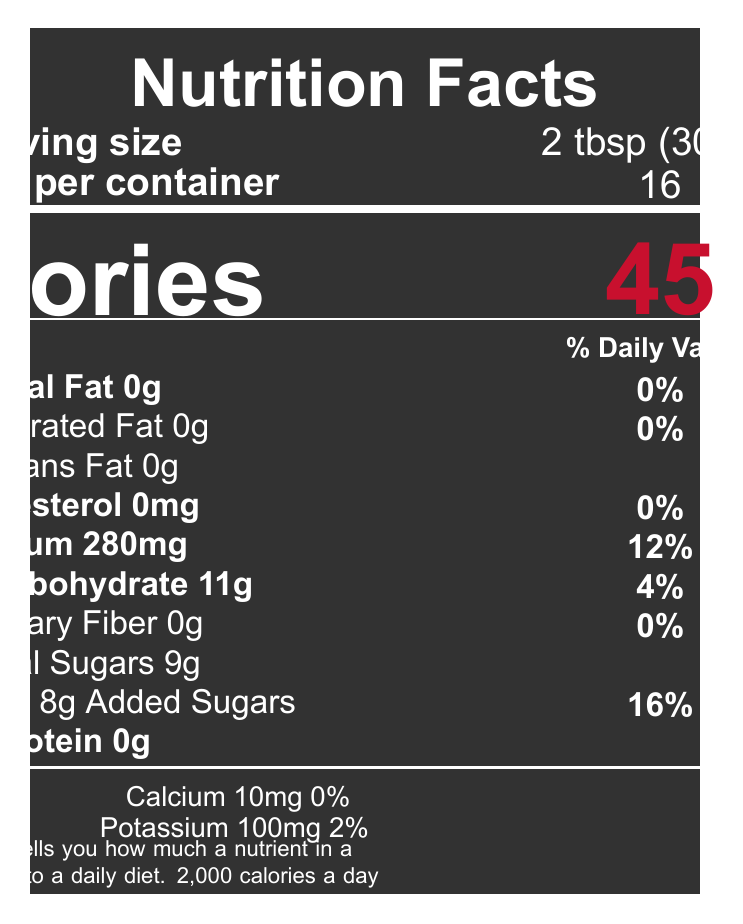What is the serving size for Pit Stop BBQ Sauce? The serving size is mentioned next to the text "Serving size" in the document.
Answer: 2 tbsp (30 ml) How many calories are in one serving of the barbecue sauce? The number of calories is specified in large, bold font in the document.
Answer: 45 What percentage of the daily value of sodium is in one serving? The document lists the sodium content as 280mg with a daily value of 12%.
Answer: 12% What ingredient listed can be a potential allergen? The allergen information specifies that soy, found in Worcestershire sauce, is a potential allergen.
Answer: Soy (in Worcestershire sauce) What is the total carbohydrate content in a serving of this sauce? The total carbohydrate content is listed as 11g with a daily value of 4%.
Answer: 11g What is the manufacturer of the Pit Stop BBQ Sauce? The manufacturer information is located at the bottom of the provided data.
Answer: Richmond Raceway Foods, Richmond, VA How should the barbecue sauce be stored after opening? The storage instructions clearly state to refrigerate after opening.
Answer: Refrigerate after opening Which vitamin is entirely absent in this barbecue sauce? A. Vitamin D B. Vitamin C C. Vitamin B12 D. Iron The document lists Vitamin D as 0mcg with a daily value of 0%.
Answer: A. Vitamin D How much dietary fiber does a serving of the barbecue sauce contain? The dietary fiber content is listed as 0g with a daily value of 0%.
Answer: 0g Is there any protein in a serving of the barbecue sauce? The protein content is listed as 0g in the document.
Answer: No Which of the following components has a daily value of 16%? 1. Total Sugars 2. Added Sugars 3. Saturated Fat 4. Potassium The added sugars are listed as 8g with a daily value of 16%.
Answer: 2. Added Sugars Is this sauce connected to any racing events? The sauce is marked as the "Official sauce of the Virginia International Raceway."
Answer: Yes What are the main flavors and ingredients in this barbecue sauce based on the ingredient list? The document lists all these items as ingredients.
Answer: Tomato paste, Apple cider vinegar, Molasses, Brown sugar, Water, Worcestershire sauce, Salt, Onion powder, Garlic powder, Black pepper, Red pepper flakes, Liquid smoke Summarize the detailed nutritional information and additional data provided about Pit Stop BBQ Sauce. This summary encapsulates the primary nutritional facts, allergen info, manufacturer, racing connection, and storage instruction provided in the document.
Answer: The Pit Stop BBQ Sauce comes in a serving size of 2 tbsp (30 ml) with 16 servings per container. Each serving has 45 calories and contains 0g of total fat, saturated fat, and trans fat, 0mg of cholesterol, 280mg of sodium (12% daily value), 11g of total carbohydrate (4% daily value), 0g of dietary fiber, 9g of total sugars which includes 8g of added sugars (16% daily value), and 0g of protein. The sauce contains traces of Vitamin D, Calcium, Iron, and Potassium. It has notable allergens due to soy in the Worcestershire sauce. The manufacturer is Richmond Raceway Foods in Richmond, VA, and it's the official sauce of the Virginia International Raceway. The storage instruction advises refrigerating after opening. What is the daily value percentage for iron in one serving of the sauce? Iron content is listed as 0.2mg with a daily value of 2%.
Answer: 2% Is the total fat content in the barbecue sauce higher than 1g? The total fat content is 0g as stated in the document.
Answer: No What is the brand name of the barbecue sauce? The product name is given as "Pit Stop BBQ Sauce."
Answer: Pit Stop BBQ Sauce What are the testimonials saying about this Pit Stop BBQ Sauce as per the document? This insight is derived from the testimonial included in the provided data.
Answer: The testimonial mentions that the sauce brings back memories of post-race cookouts and has a perfect balance of sweet and tangy flavors. Does this barbecue sauce contain any calcium? The document shows that the sauce contains 10mg of calcium with a daily value of 0%.
Answer: Yes, it contains 10mg of calcium. Who is the intended user or the demographic for this barbecue sauce? The document does not provide any information about the intended user or demographic.
Answer: Not specified. What is the total number of servings in one container of the sauce? The number of servings per container is listed as 16 in the document.
Answer: 16 